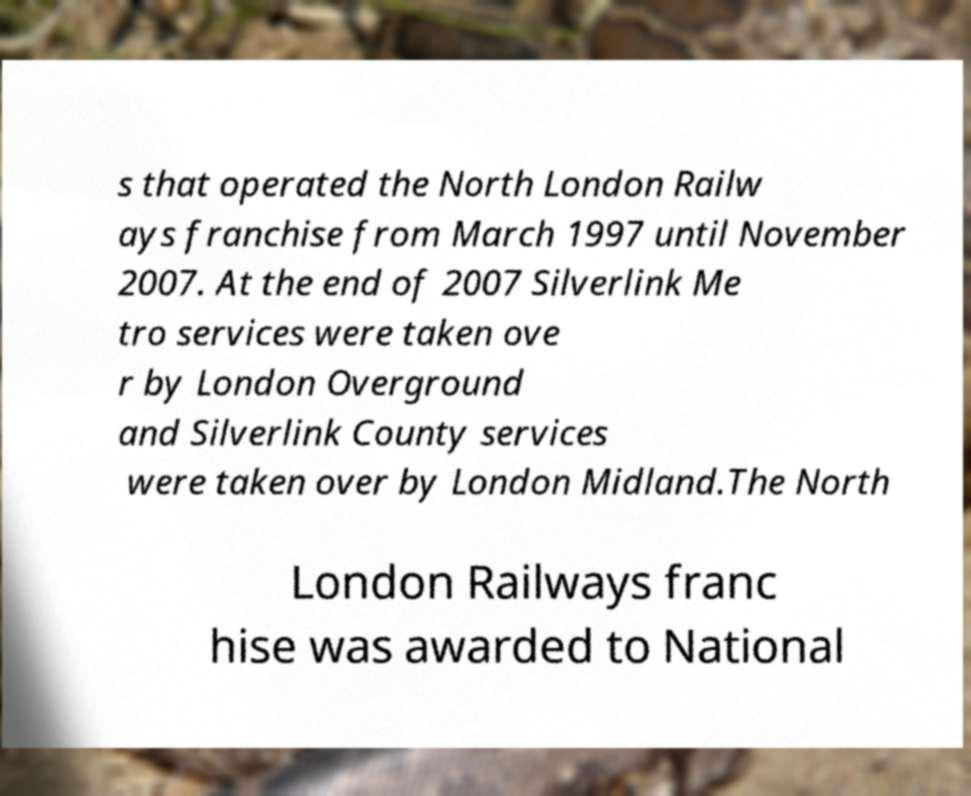For documentation purposes, I need the text within this image transcribed. Could you provide that? s that operated the North London Railw ays franchise from March 1997 until November 2007. At the end of 2007 Silverlink Me tro services were taken ove r by London Overground and Silverlink County services were taken over by London Midland.The North London Railways franc hise was awarded to National 